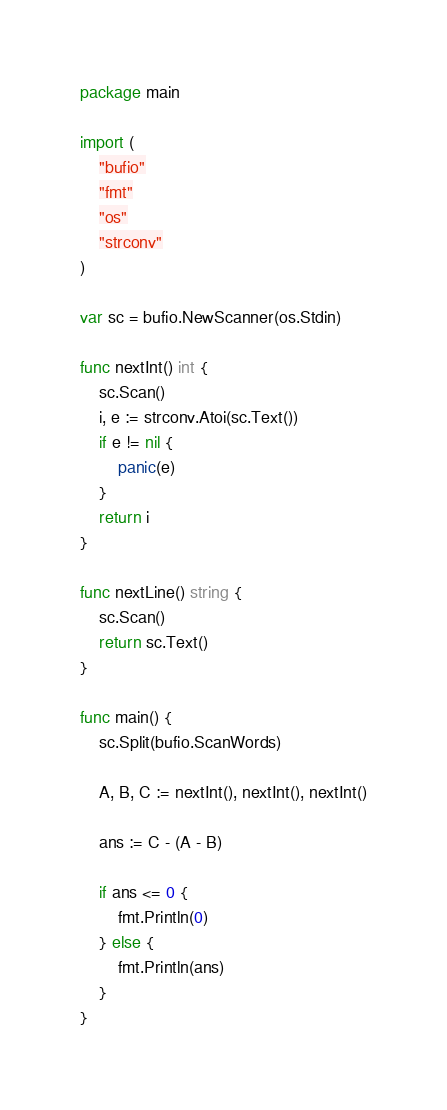<code> <loc_0><loc_0><loc_500><loc_500><_Go_>package main

import (
	"bufio"
	"fmt"
	"os"
	"strconv"
)

var sc = bufio.NewScanner(os.Stdin)

func nextInt() int {
	sc.Scan()
	i, e := strconv.Atoi(sc.Text())
	if e != nil {
		panic(e)
	}
	return i
}

func nextLine() string {
	sc.Scan()
	return sc.Text()
}

func main() {
	sc.Split(bufio.ScanWords)

	A, B, C := nextInt(), nextInt(), nextInt()

	ans := C - (A - B)

	if ans <= 0 {
		fmt.Println(0)
	} else {
		fmt.Println(ans)
	}
}
</code> 